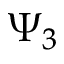Convert formula to latex. <formula><loc_0><loc_0><loc_500><loc_500>\Psi _ { 3 }</formula> 